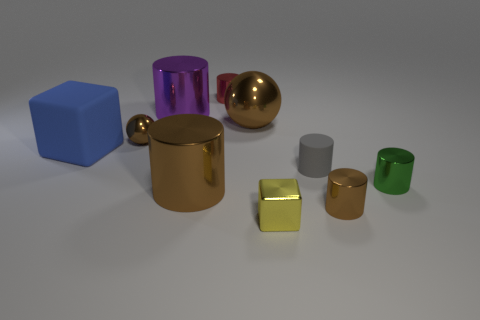There is a tiny cylinder that is behind the brown shiny ball that is to the right of the big cylinder in front of the big purple cylinder; what is its color?
Keep it short and to the point. Red. Are there fewer green metal cylinders to the left of the blue thing than large yellow cylinders?
Provide a succinct answer. No. Does the tiny shiny object that is behind the large brown metal ball have the same shape as the large brown thing that is left of the big brown ball?
Provide a short and direct response. Yes. How many things are either tiny metallic things that are in front of the tiny brown shiny cylinder or green things?
Your response must be concise. 2. What material is the big ball that is the same color as the tiny ball?
Provide a short and direct response. Metal. Are there any tiny yellow cubes to the right of the sphere right of the shiny object that is behind the big purple cylinder?
Provide a succinct answer. Yes. Are there fewer small rubber things that are left of the big purple shiny object than metallic cubes that are in front of the tiny gray cylinder?
Your answer should be compact. Yes. There is a large ball that is made of the same material as the yellow thing; what is its color?
Offer a very short reply. Brown. There is a matte object that is to the right of the brown sphere that is on the left side of the red metallic object; what is its color?
Your answer should be very brief. Gray. Is there a shiny thing of the same color as the big ball?
Ensure brevity in your answer.  Yes. 